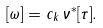<formula> <loc_0><loc_0><loc_500><loc_500>[ \omega ] = c _ { k } \, \nu ^ { * } [ \tau ] .</formula> 